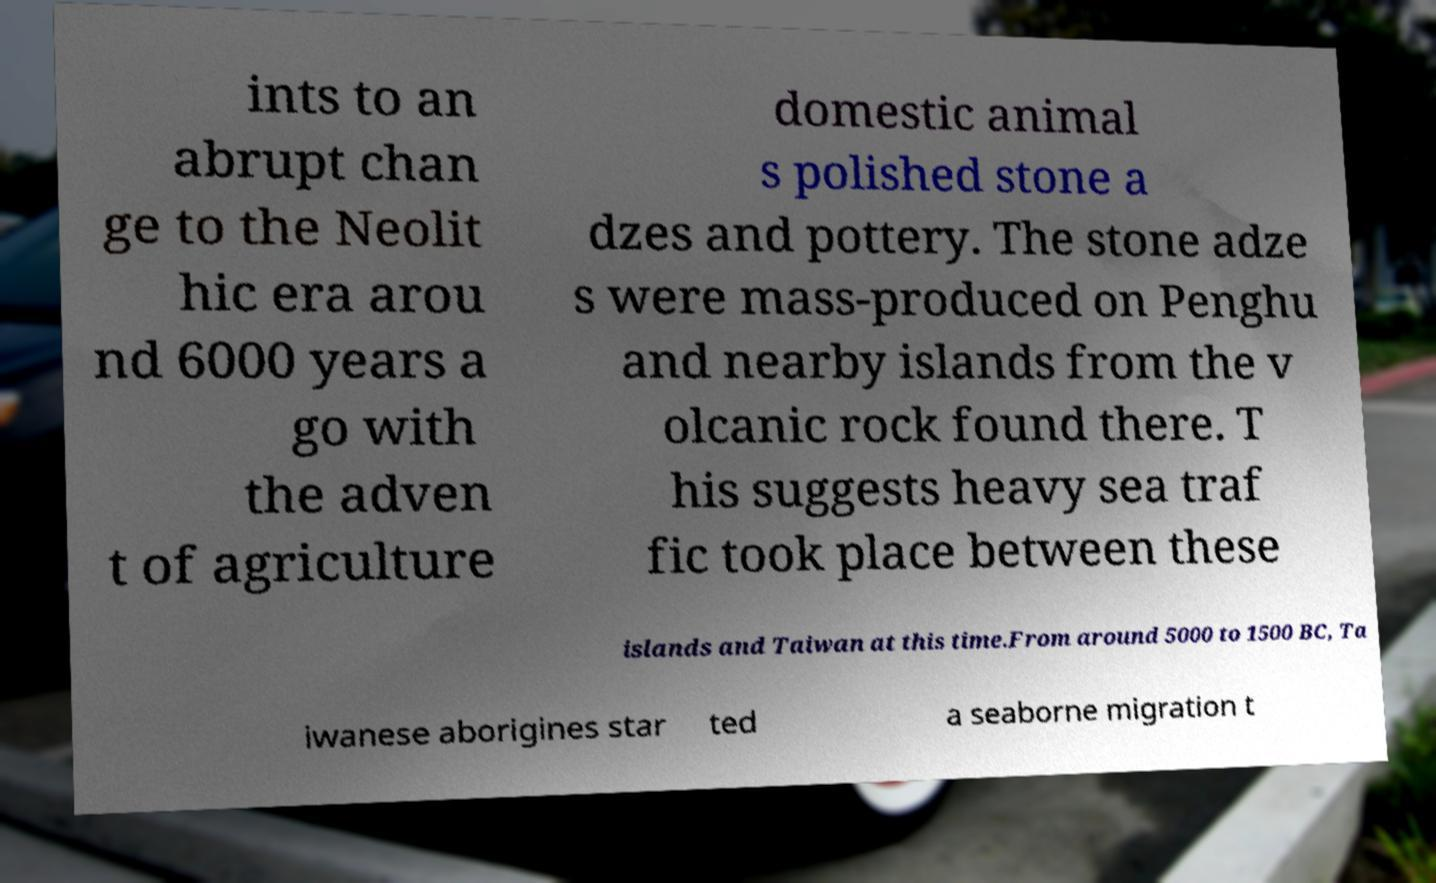There's text embedded in this image that I need extracted. Can you transcribe it verbatim? ints to an abrupt chan ge to the Neolit hic era arou nd 6000 years a go with the adven t of agriculture domestic animal s polished stone a dzes and pottery. The stone adze s were mass-produced on Penghu and nearby islands from the v olcanic rock found there. T his suggests heavy sea traf fic took place between these islands and Taiwan at this time.From around 5000 to 1500 BC, Ta iwanese aborigines star ted a seaborne migration t 